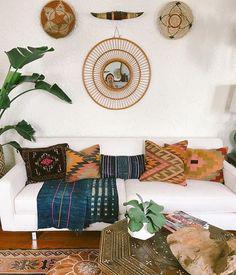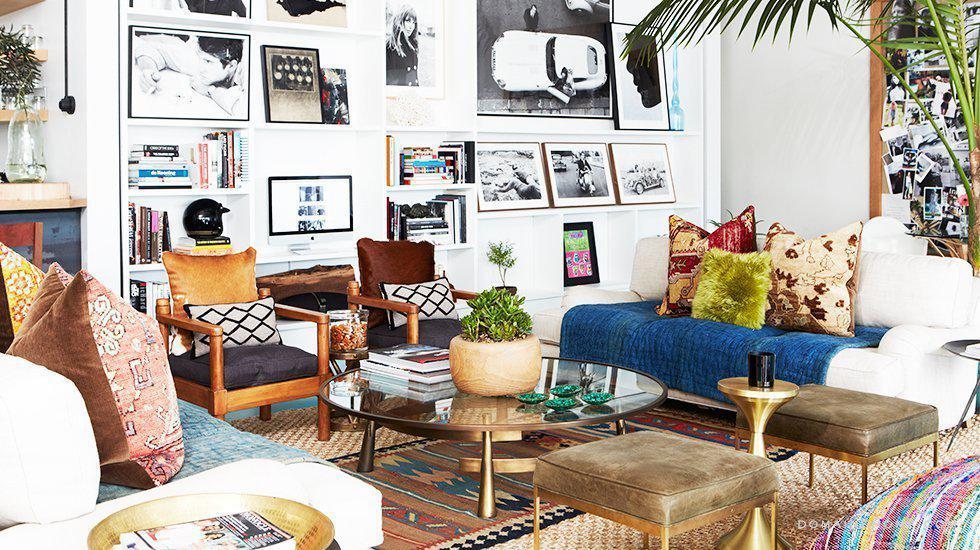The first image is the image on the left, the second image is the image on the right. For the images shown, is this caption "One image contains a single square pillow with Aztec-style geometric print, and the other image contains at least three pillows with coordinating geometric prints." true? Answer yes or no. No. 